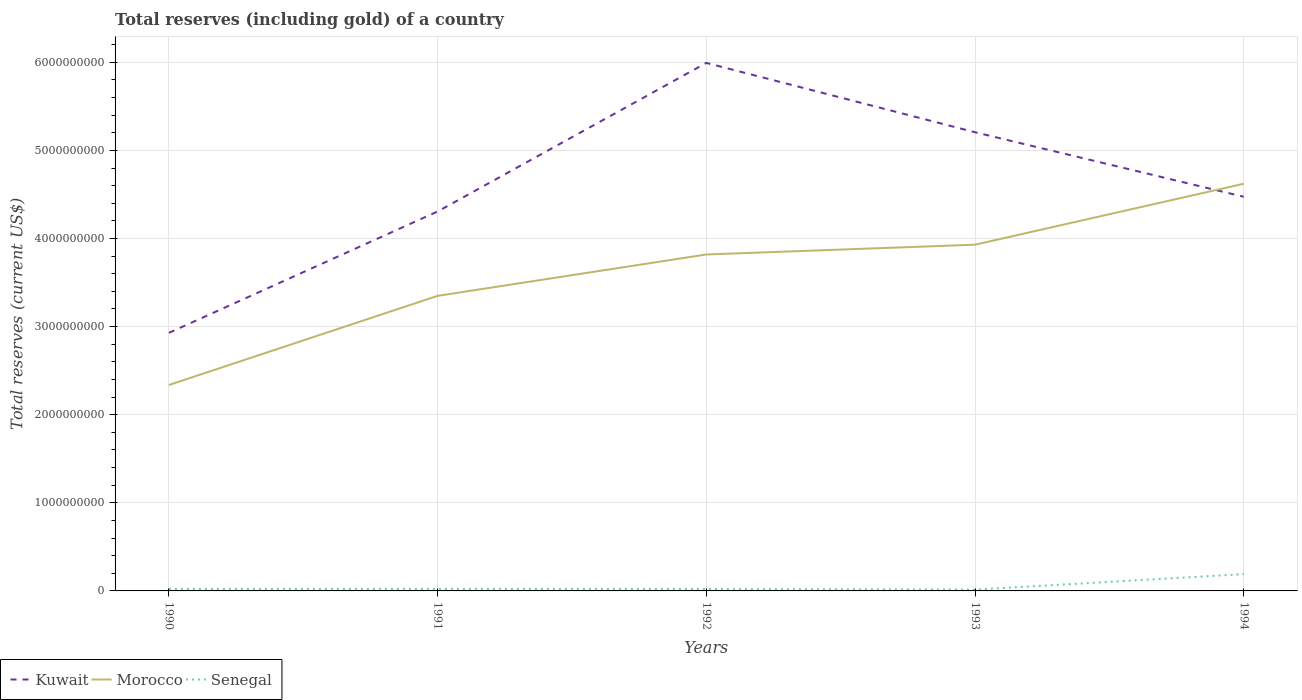How many different coloured lines are there?
Your response must be concise. 3. Does the line corresponding to Morocco intersect with the line corresponding to Kuwait?
Give a very brief answer. Yes. Across all years, what is the maximum total reserves (including gold) in Senegal?
Offer a very short reply. 1.47e+07. In which year was the total reserves (including gold) in Morocco maximum?
Keep it short and to the point. 1990. What is the total total reserves (including gold) in Kuwait in the graph?
Offer a terse response. -1.69e+09. What is the difference between the highest and the second highest total reserves (including gold) in Morocco?
Your answer should be compact. 2.28e+09. What is the difference between the highest and the lowest total reserves (including gold) in Morocco?
Your answer should be compact. 3. Is the total reserves (including gold) in Morocco strictly greater than the total reserves (including gold) in Kuwait over the years?
Make the answer very short. No. How many lines are there?
Your answer should be compact. 3. How many years are there in the graph?
Provide a succinct answer. 5. What is the difference between two consecutive major ticks on the Y-axis?
Offer a very short reply. 1.00e+09. Are the values on the major ticks of Y-axis written in scientific E-notation?
Provide a succinct answer. No. How many legend labels are there?
Give a very brief answer. 3. What is the title of the graph?
Offer a terse response. Total reserves (including gold) of a country. What is the label or title of the X-axis?
Make the answer very short. Years. What is the label or title of the Y-axis?
Make the answer very short. Total reserves (current US$). What is the Total reserves (current US$) in Kuwait in 1990?
Give a very brief answer. 2.93e+09. What is the Total reserves (current US$) in Morocco in 1990?
Offer a very short reply. 2.34e+09. What is the Total reserves (current US$) of Senegal in 1990?
Provide a short and direct response. 2.21e+07. What is the Total reserves (current US$) in Kuwait in 1991?
Keep it short and to the point. 4.31e+09. What is the Total reserves (current US$) in Morocco in 1991?
Your answer should be very brief. 3.35e+09. What is the Total reserves (current US$) in Senegal in 1991?
Your response must be concise. 2.35e+07. What is the Total reserves (current US$) of Kuwait in 1992?
Give a very brief answer. 5.99e+09. What is the Total reserves (current US$) of Morocco in 1992?
Provide a short and direct response. 3.82e+09. What is the Total reserves (current US$) in Senegal in 1992?
Ensure brevity in your answer.  2.20e+07. What is the Total reserves (current US$) of Kuwait in 1993?
Offer a very short reply. 5.21e+09. What is the Total reserves (current US$) in Morocco in 1993?
Your answer should be compact. 3.93e+09. What is the Total reserves (current US$) in Senegal in 1993?
Offer a terse response. 1.47e+07. What is the Total reserves (current US$) in Kuwait in 1994?
Ensure brevity in your answer.  4.47e+09. What is the Total reserves (current US$) of Morocco in 1994?
Make the answer very short. 4.62e+09. What is the Total reserves (current US$) of Senegal in 1994?
Your response must be concise. 1.91e+08. Across all years, what is the maximum Total reserves (current US$) in Kuwait?
Provide a short and direct response. 5.99e+09. Across all years, what is the maximum Total reserves (current US$) of Morocco?
Provide a short and direct response. 4.62e+09. Across all years, what is the maximum Total reserves (current US$) of Senegal?
Ensure brevity in your answer.  1.91e+08. Across all years, what is the minimum Total reserves (current US$) of Kuwait?
Give a very brief answer. 2.93e+09. Across all years, what is the minimum Total reserves (current US$) of Morocco?
Your response must be concise. 2.34e+09. Across all years, what is the minimum Total reserves (current US$) of Senegal?
Your response must be concise. 1.47e+07. What is the total Total reserves (current US$) in Kuwait in the graph?
Make the answer very short. 2.29e+1. What is the total Total reserves (current US$) in Morocco in the graph?
Offer a terse response. 1.81e+1. What is the total Total reserves (current US$) in Senegal in the graph?
Offer a very short reply. 2.73e+08. What is the difference between the Total reserves (current US$) of Kuwait in 1990 and that in 1991?
Provide a short and direct response. -1.38e+09. What is the difference between the Total reserves (current US$) of Morocco in 1990 and that in 1991?
Offer a very short reply. -1.01e+09. What is the difference between the Total reserves (current US$) of Senegal in 1990 and that in 1991?
Provide a short and direct response. -1.35e+06. What is the difference between the Total reserves (current US$) of Kuwait in 1990 and that in 1992?
Provide a short and direct response. -3.06e+09. What is the difference between the Total reserves (current US$) of Morocco in 1990 and that in 1992?
Your answer should be compact. -1.48e+09. What is the difference between the Total reserves (current US$) in Senegal in 1990 and that in 1992?
Give a very brief answer. 8.74e+04. What is the difference between the Total reserves (current US$) of Kuwait in 1990 and that in 1993?
Offer a very short reply. -2.28e+09. What is the difference between the Total reserves (current US$) in Morocco in 1990 and that in 1993?
Ensure brevity in your answer.  -1.59e+09. What is the difference between the Total reserves (current US$) of Senegal in 1990 and that in 1993?
Make the answer very short. 7.38e+06. What is the difference between the Total reserves (current US$) in Kuwait in 1990 and that in 1994?
Offer a terse response. -1.54e+09. What is the difference between the Total reserves (current US$) in Morocco in 1990 and that in 1994?
Provide a short and direct response. -2.28e+09. What is the difference between the Total reserves (current US$) in Senegal in 1990 and that in 1994?
Provide a succinct answer. -1.69e+08. What is the difference between the Total reserves (current US$) of Kuwait in 1991 and that in 1992?
Your response must be concise. -1.69e+09. What is the difference between the Total reserves (current US$) in Morocco in 1991 and that in 1992?
Provide a short and direct response. -4.70e+08. What is the difference between the Total reserves (current US$) in Senegal in 1991 and that in 1992?
Keep it short and to the point. 1.43e+06. What is the difference between the Total reserves (current US$) in Kuwait in 1991 and that in 1993?
Give a very brief answer. -8.99e+08. What is the difference between the Total reserves (current US$) of Morocco in 1991 and that in 1993?
Your answer should be compact. -5.81e+08. What is the difference between the Total reserves (current US$) of Senegal in 1991 and that in 1993?
Your answer should be compact. 8.73e+06. What is the difference between the Total reserves (current US$) of Kuwait in 1991 and that in 1994?
Your answer should be compact. -1.67e+08. What is the difference between the Total reserves (current US$) in Morocco in 1991 and that in 1994?
Your answer should be compact. -1.27e+09. What is the difference between the Total reserves (current US$) of Senegal in 1991 and that in 1994?
Your answer should be very brief. -1.67e+08. What is the difference between the Total reserves (current US$) of Kuwait in 1992 and that in 1993?
Keep it short and to the point. 7.87e+08. What is the difference between the Total reserves (current US$) of Morocco in 1992 and that in 1993?
Your response must be concise. -1.11e+08. What is the difference between the Total reserves (current US$) of Senegal in 1992 and that in 1993?
Keep it short and to the point. 7.29e+06. What is the difference between the Total reserves (current US$) in Kuwait in 1992 and that in 1994?
Your answer should be very brief. 1.52e+09. What is the difference between the Total reserves (current US$) in Morocco in 1992 and that in 1994?
Ensure brevity in your answer.  -8.03e+08. What is the difference between the Total reserves (current US$) in Senegal in 1992 and that in 1994?
Provide a short and direct response. -1.69e+08. What is the difference between the Total reserves (current US$) of Kuwait in 1993 and that in 1994?
Your answer should be compact. 7.32e+08. What is the difference between the Total reserves (current US$) in Morocco in 1993 and that in 1994?
Provide a succinct answer. -6.92e+08. What is the difference between the Total reserves (current US$) in Senegal in 1993 and that in 1994?
Ensure brevity in your answer.  -1.76e+08. What is the difference between the Total reserves (current US$) in Kuwait in 1990 and the Total reserves (current US$) in Morocco in 1991?
Provide a short and direct response. -4.20e+08. What is the difference between the Total reserves (current US$) in Kuwait in 1990 and the Total reserves (current US$) in Senegal in 1991?
Provide a short and direct response. 2.91e+09. What is the difference between the Total reserves (current US$) in Morocco in 1990 and the Total reserves (current US$) in Senegal in 1991?
Give a very brief answer. 2.31e+09. What is the difference between the Total reserves (current US$) of Kuwait in 1990 and the Total reserves (current US$) of Morocco in 1992?
Offer a very short reply. -8.89e+08. What is the difference between the Total reserves (current US$) in Kuwait in 1990 and the Total reserves (current US$) in Senegal in 1992?
Offer a terse response. 2.91e+09. What is the difference between the Total reserves (current US$) of Morocco in 1990 and the Total reserves (current US$) of Senegal in 1992?
Your answer should be very brief. 2.32e+09. What is the difference between the Total reserves (current US$) of Kuwait in 1990 and the Total reserves (current US$) of Morocco in 1993?
Ensure brevity in your answer.  -1.00e+09. What is the difference between the Total reserves (current US$) in Kuwait in 1990 and the Total reserves (current US$) in Senegal in 1993?
Your response must be concise. 2.91e+09. What is the difference between the Total reserves (current US$) in Morocco in 1990 and the Total reserves (current US$) in Senegal in 1993?
Your answer should be compact. 2.32e+09. What is the difference between the Total reserves (current US$) of Kuwait in 1990 and the Total reserves (current US$) of Morocco in 1994?
Your response must be concise. -1.69e+09. What is the difference between the Total reserves (current US$) of Kuwait in 1990 and the Total reserves (current US$) of Senegal in 1994?
Your answer should be compact. 2.74e+09. What is the difference between the Total reserves (current US$) in Morocco in 1990 and the Total reserves (current US$) in Senegal in 1994?
Make the answer very short. 2.15e+09. What is the difference between the Total reserves (current US$) of Kuwait in 1991 and the Total reserves (current US$) of Morocco in 1992?
Your answer should be compact. 4.88e+08. What is the difference between the Total reserves (current US$) in Kuwait in 1991 and the Total reserves (current US$) in Senegal in 1992?
Ensure brevity in your answer.  4.28e+09. What is the difference between the Total reserves (current US$) of Morocco in 1991 and the Total reserves (current US$) of Senegal in 1992?
Keep it short and to the point. 3.33e+09. What is the difference between the Total reserves (current US$) of Kuwait in 1991 and the Total reserves (current US$) of Morocco in 1993?
Ensure brevity in your answer.  3.77e+08. What is the difference between the Total reserves (current US$) of Kuwait in 1991 and the Total reserves (current US$) of Senegal in 1993?
Provide a short and direct response. 4.29e+09. What is the difference between the Total reserves (current US$) in Morocco in 1991 and the Total reserves (current US$) in Senegal in 1993?
Keep it short and to the point. 3.33e+09. What is the difference between the Total reserves (current US$) in Kuwait in 1991 and the Total reserves (current US$) in Morocco in 1994?
Your answer should be compact. -3.15e+08. What is the difference between the Total reserves (current US$) in Kuwait in 1991 and the Total reserves (current US$) in Senegal in 1994?
Your answer should be compact. 4.12e+09. What is the difference between the Total reserves (current US$) of Morocco in 1991 and the Total reserves (current US$) of Senegal in 1994?
Provide a succinct answer. 3.16e+09. What is the difference between the Total reserves (current US$) of Kuwait in 1992 and the Total reserves (current US$) of Morocco in 1993?
Your answer should be very brief. 2.06e+09. What is the difference between the Total reserves (current US$) in Kuwait in 1992 and the Total reserves (current US$) in Senegal in 1993?
Ensure brevity in your answer.  5.98e+09. What is the difference between the Total reserves (current US$) in Morocco in 1992 and the Total reserves (current US$) in Senegal in 1993?
Make the answer very short. 3.80e+09. What is the difference between the Total reserves (current US$) in Kuwait in 1992 and the Total reserves (current US$) in Morocco in 1994?
Your response must be concise. 1.37e+09. What is the difference between the Total reserves (current US$) in Kuwait in 1992 and the Total reserves (current US$) in Senegal in 1994?
Provide a short and direct response. 5.80e+09. What is the difference between the Total reserves (current US$) in Morocco in 1992 and the Total reserves (current US$) in Senegal in 1994?
Your response must be concise. 3.63e+09. What is the difference between the Total reserves (current US$) in Kuwait in 1993 and the Total reserves (current US$) in Morocco in 1994?
Ensure brevity in your answer.  5.84e+08. What is the difference between the Total reserves (current US$) in Kuwait in 1993 and the Total reserves (current US$) in Senegal in 1994?
Your answer should be compact. 5.02e+09. What is the difference between the Total reserves (current US$) in Morocco in 1993 and the Total reserves (current US$) in Senegal in 1994?
Your response must be concise. 3.74e+09. What is the average Total reserves (current US$) in Kuwait per year?
Provide a succinct answer. 4.58e+09. What is the average Total reserves (current US$) in Morocco per year?
Your answer should be very brief. 3.61e+09. What is the average Total reserves (current US$) of Senegal per year?
Your response must be concise. 5.46e+07. In the year 1990, what is the difference between the Total reserves (current US$) in Kuwait and Total reserves (current US$) in Morocco?
Offer a terse response. 5.92e+08. In the year 1990, what is the difference between the Total reserves (current US$) of Kuwait and Total reserves (current US$) of Senegal?
Provide a succinct answer. 2.91e+09. In the year 1990, what is the difference between the Total reserves (current US$) of Morocco and Total reserves (current US$) of Senegal?
Ensure brevity in your answer.  2.32e+09. In the year 1991, what is the difference between the Total reserves (current US$) in Kuwait and Total reserves (current US$) in Morocco?
Provide a short and direct response. 9.58e+08. In the year 1991, what is the difference between the Total reserves (current US$) of Kuwait and Total reserves (current US$) of Senegal?
Your answer should be very brief. 4.28e+09. In the year 1991, what is the difference between the Total reserves (current US$) in Morocco and Total reserves (current US$) in Senegal?
Ensure brevity in your answer.  3.33e+09. In the year 1992, what is the difference between the Total reserves (current US$) in Kuwait and Total reserves (current US$) in Morocco?
Give a very brief answer. 2.17e+09. In the year 1992, what is the difference between the Total reserves (current US$) in Kuwait and Total reserves (current US$) in Senegal?
Offer a very short reply. 5.97e+09. In the year 1992, what is the difference between the Total reserves (current US$) of Morocco and Total reserves (current US$) of Senegal?
Offer a terse response. 3.80e+09. In the year 1993, what is the difference between the Total reserves (current US$) in Kuwait and Total reserves (current US$) in Morocco?
Provide a succinct answer. 1.28e+09. In the year 1993, what is the difference between the Total reserves (current US$) of Kuwait and Total reserves (current US$) of Senegal?
Offer a terse response. 5.19e+09. In the year 1993, what is the difference between the Total reserves (current US$) in Morocco and Total reserves (current US$) in Senegal?
Provide a succinct answer. 3.92e+09. In the year 1994, what is the difference between the Total reserves (current US$) of Kuwait and Total reserves (current US$) of Morocco?
Offer a very short reply. -1.48e+08. In the year 1994, what is the difference between the Total reserves (current US$) in Kuwait and Total reserves (current US$) in Senegal?
Your answer should be very brief. 4.28e+09. In the year 1994, what is the difference between the Total reserves (current US$) of Morocco and Total reserves (current US$) of Senegal?
Ensure brevity in your answer.  4.43e+09. What is the ratio of the Total reserves (current US$) of Kuwait in 1990 to that in 1991?
Your answer should be very brief. 0.68. What is the ratio of the Total reserves (current US$) of Morocco in 1990 to that in 1991?
Your answer should be compact. 0.7. What is the ratio of the Total reserves (current US$) of Senegal in 1990 to that in 1991?
Offer a terse response. 0.94. What is the ratio of the Total reserves (current US$) in Kuwait in 1990 to that in 1992?
Provide a succinct answer. 0.49. What is the ratio of the Total reserves (current US$) of Morocco in 1990 to that in 1992?
Provide a succinct answer. 0.61. What is the ratio of the Total reserves (current US$) in Kuwait in 1990 to that in 1993?
Keep it short and to the point. 0.56. What is the ratio of the Total reserves (current US$) in Morocco in 1990 to that in 1993?
Provide a short and direct response. 0.59. What is the ratio of the Total reserves (current US$) of Senegal in 1990 to that in 1993?
Provide a short and direct response. 1.5. What is the ratio of the Total reserves (current US$) in Kuwait in 1990 to that in 1994?
Your response must be concise. 0.65. What is the ratio of the Total reserves (current US$) in Morocco in 1990 to that in 1994?
Offer a terse response. 0.51. What is the ratio of the Total reserves (current US$) of Senegal in 1990 to that in 1994?
Keep it short and to the point. 0.12. What is the ratio of the Total reserves (current US$) of Kuwait in 1991 to that in 1992?
Your response must be concise. 0.72. What is the ratio of the Total reserves (current US$) in Morocco in 1991 to that in 1992?
Make the answer very short. 0.88. What is the ratio of the Total reserves (current US$) in Senegal in 1991 to that in 1992?
Your response must be concise. 1.07. What is the ratio of the Total reserves (current US$) in Kuwait in 1991 to that in 1993?
Offer a terse response. 0.83. What is the ratio of the Total reserves (current US$) in Morocco in 1991 to that in 1993?
Provide a succinct answer. 0.85. What is the ratio of the Total reserves (current US$) of Senegal in 1991 to that in 1993?
Ensure brevity in your answer.  1.59. What is the ratio of the Total reserves (current US$) in Kuwait in 1991 to that in 1994?
Your response must be concise. 0.96. What is the ratio of the Total reserves (current US$) in Morocco in 1991 to that in 1994?
Give a very brief answer. 0.72. What is the ratio of the Total reserves (current US$) of Senegal in 1991 to that in 1994?
Your response must be concise. 0.12. What is the ratio of the Total reserves (current US$) of Kuwait in 1992 to that in 1993?
Make the answer very short. 1.15. What is the ratio of the Total reserves (current US$) in Morocco in 1992 to that in 1993?
Keep it short and to the point. 0.97. What is the ratio of the Total reserves (current US$) in Senegal in 1992 to that in 1993?
Provide a succinct answer. 1.49. What is the ratio of the Total reserves (current US$) of Kuwait in 1992 to that in 1994?
Provide a short and direct response. 1.34. What is the ratio of the Total reserves (current US$) of Morocco in 1992 to that in 1994?
Offer a very short reply. 0.83. What is the ratio of the Total reserves (current US$) of Senegal in 1992 to that in 1994?
Make the answer very short. 0.12. What is the ratio of the Total reserves (current US$) of Kuwait in 1993 to that in 1994?
Your answer should be very brief. 1.16. What is the ratio of the Total reserves (current US$) in Morocco in 1993 to that in 1994?
Your answer should be very brief. 0.85. What is the ratio of the Total reserves (current US$) of Senegal in 1993 to that in 1994?
Your answer should be compact. 0.08. What is the difference between the highest and the second highest Total reserves (current US$) of Kuwait?
Your answer should be compact. 7.87e+08. What is the difference between the highest and the second highest Total reserves (current US$) in Morocco?
Keep it short and to the point. 6.92e+08. What is the difference between the highest and the second highest Total reserves (current US$) of Senegal?
Keep it short and to the point. 1.67e+08. What is the difference between the highest and the lowest Total reserves (current US$) in Kuwait?
Offer a very short reply. 3.06e+09. What is the difference between the highest and the lowest Total reserves (current US$) in Morocco?
Give a very brief answer. 2.28e+09. What is the difference between the highest and the lowest Total reserves (current US$) of Senegal?
Your answer should be compact. 1.76e+08. 